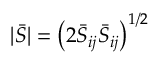<formula> <loc_0><loc_0><loc_500><loc_500>| \bar { S } | = \left ( 2 \bar { S } _ { i j } \bar { S } _ { i j } \right ) ^ { 1 / 2 }</formula> 